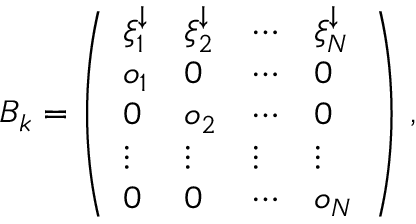Convert formula to latex. <formula><loc_0><loc_0><loc_500><loc_500>\begin{array} { r } { B _ { k } = \left ( \begin{array} { l l l l } { \xi _ { 1 } ^ { \downarrow } } & { \xi _ { 2 } ^ { \downarrow } } & { \cdots } & { \xi _ { N } ^ { \downarrow } } \\ { o _ { 1 } } & { 0 } & { \cdots } & { 0 } \\ { 0 } & { o _ { 2 } } & { \cdots } & { 0 } \\ { \vdots } & { \vdots } & { \vdots } & { \vdots } \\ { 0 } & { 0 } & { \cdots } & { o _ { N } } \end{array} \right ) \, , } \end{array}</formula> 